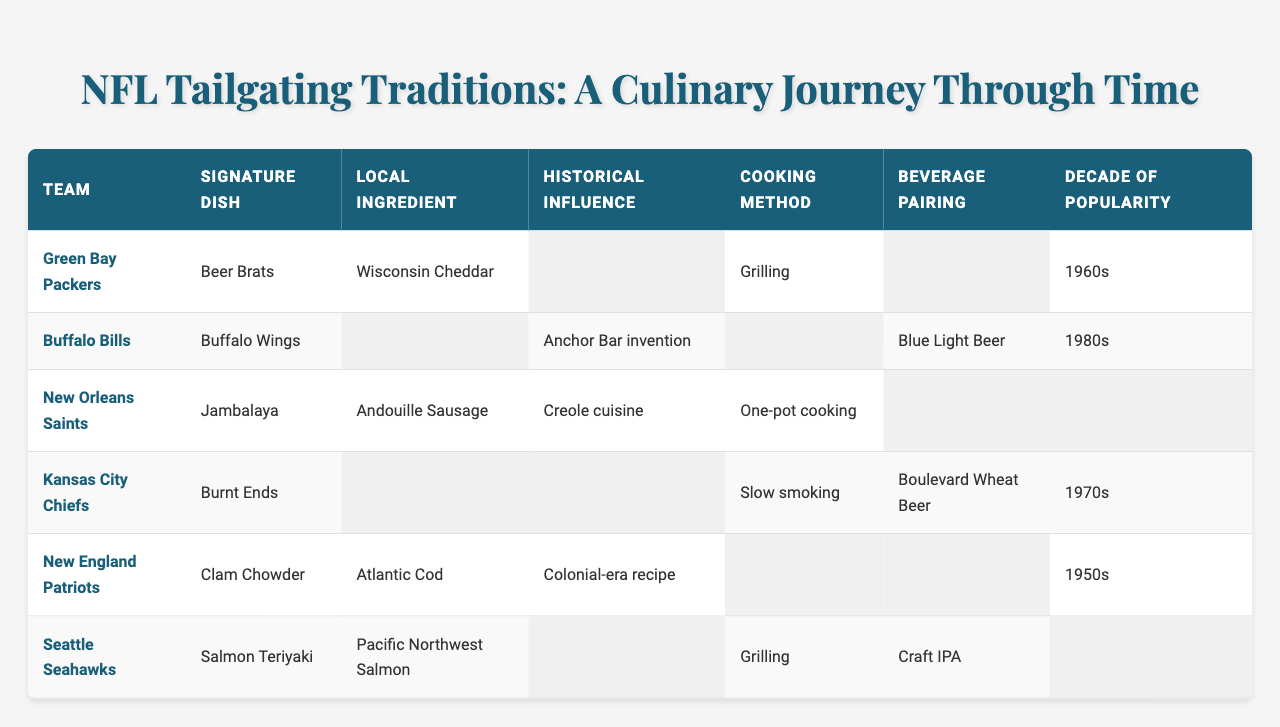What is the signature dish of the Green Bay Packers? The table lists the Green Bay Packers under the "team" column and shows their "Signature Dish" as "Beer Brats".
Answer: Beer Brats Which team has "Jambalaya" as their signature dish? The table indicates that the New Orleans Saints have "Jambalaya" listed as their "Signature Dish".
Answer: New Orleans Saints What beverage is paired with "Buffalo Wings"? The entry for the Buffalo Bills shows that "Buffalo Wings" is paired with "Blue Light Beer" in the "Beverage Pairing" column.
Answer: Blue Light Beer How many teams have a cooking method of "Grilling"? The Green Bay Packers and Seattle Seahawks both have "Grilling" listed as their "Cooking Method", which gives us a total of two.
Answer: 2 Which local ingredient is unique to the New England Patriots? The table lists "Atlantic Cod" under "Local Ingredient" specifically for the New England Patriots, indicating it is unique to them compared to other teams.
Answer: Atlantic Cod What decade of popularity is associated with "Burnt Ends"? According to the data for the Kansas City Chiefs, "Burnt Ends" is noted with the "Decade of Popularity" as the 1970s.
Answer: 1970s Is "Andouille Sausage" the local ingredient for any team? Yes, the data indicates that "Andouille Sausage" is the local ingredient for the New Orleans Saints.
Answer: Yes Which team's beverages are associated with craft beers? The Seattle Seahawks are associated with "Craft IPA" in the "Beverage Pairing".
Answer: Seattle Seahawks What historical influence is associated with New England Patriots' tailgating food? The table specifies that the New England Patriots' food has a "Historical Influence" derived from a "Colonial-era recipe".
Answer: Colonial-era recipe Which team features "Slow smoking" as their cooking method, and what is their decade of popularity? The Kansas City Chiefs use "Slow smoking" for their cooking method, which is popular in the 1970s according to the table.
Answer: Kansas City Chiefs, 1970s What is the common cooking method for both the Green Bay Packers and the Seattle Seahawks? The Green Bay Packers and the Seattle Seahawks both utilize "Grilling" as their cooking method, as noted in the table.
Answer: Grilling 